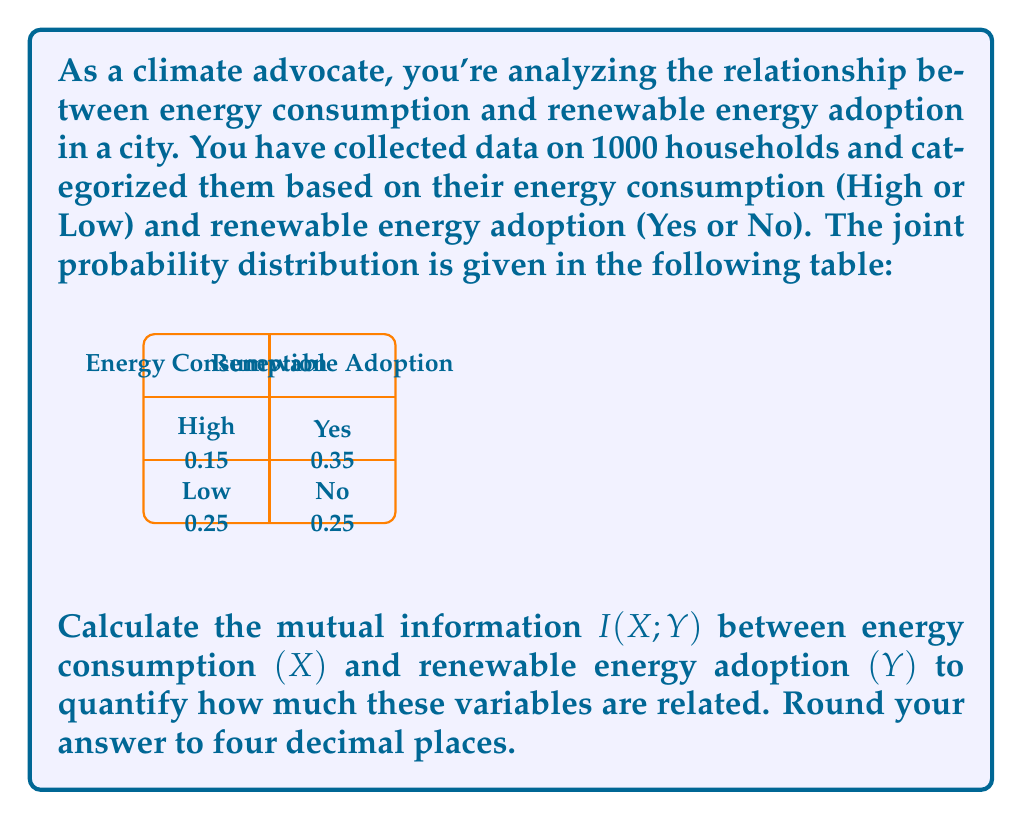Can you answer this question? To calculate the mutual information $I(X;Y)$, we'll follow these steps:

1) First, we need to calculate the marginal probabilities:
   $P(X=\text{High}) = 0.15 + 0.35 = 0.5$
   $P(X=\text{Low}) = 0.25 + 0.25 = 0.5$
   $P(Y=\text{Yes}) = 0.15 + 0.25 = 0.4$
   $P(Y=\text{No}) = 0.35 + 0.25 = 0.6$

2) The formula for mutual information is:
   $$I(X;Y) = \sum_{x \in X} \sum_{y \in Y} P(x,y) \log_2 \frac{P(x,y)}{P(x)P(y)}$$

3) Let's calculate each term:
   For $X=\text{High}, Y=\text{Yes}$:
   $0.15 \log_2 \frac{0.15}{0.5 \times 0.4} = 0.15 \log_2 0.75 = -0.0614$

   For $X=\text{High}, Y=\text{No}$:
   $0.35 \log_2 \frac{0.35}{0.5 \times 0.6} = 0.35 \log_2 1.1667 = 0.0220$

   For $X=\text{Low}, Y=\text{Yes}$:
   $0.25 \log_2 \frac{0.25}{0.5 \times 0.4} = 0.25 \log_2 1.25 = 0.0614$

   For $X=\text{Low}, Y=\text{No}$:
   $0.25 \log_2 \frac{0.25}{0.5 \times 0.6} = 0.25 \log_2 0.8333 = -0.0220$

4) Sum all these terms:
   $I(X;Y) = -0.0614 + 0.0220 + 0.0614 - 0.0220 = 0$

5) Rounding to four decimal places:
   $I(X;Y) = 0.0000$ bits

The mutual information is 0, indicating that energy consumption and renewable energy adoption are independent in this dataset.
Answer: $0.0000$ bits 